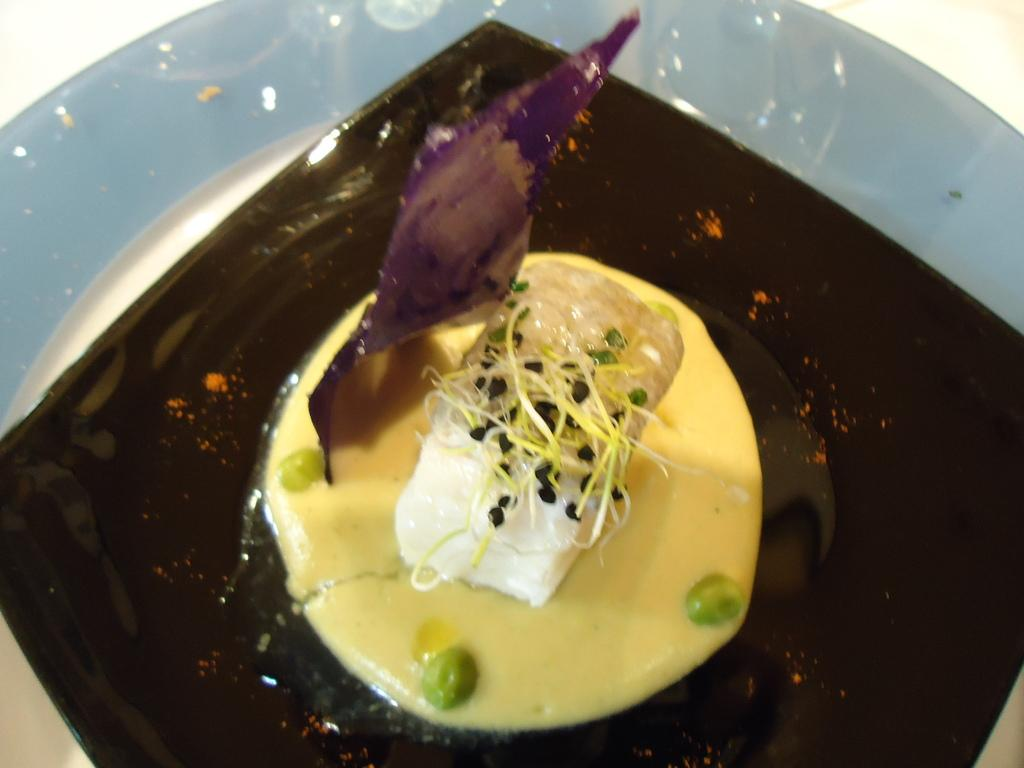What is placed on a plate in the image? There is food placed in a plate in the image. Can you describe the type of food on the plate? The provided facts do not specify the type of food on the plate. Is there any cutlery or utensils visible in the image? The provided facts do not mention any cutlery or utensils. How many passengers are visible in the image? There are no passengers present in the image, as it only features a plate with food. 